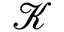<formula> <loc_0><loc_0><loc_500><loc_500>\mathcal { K }</formula> 